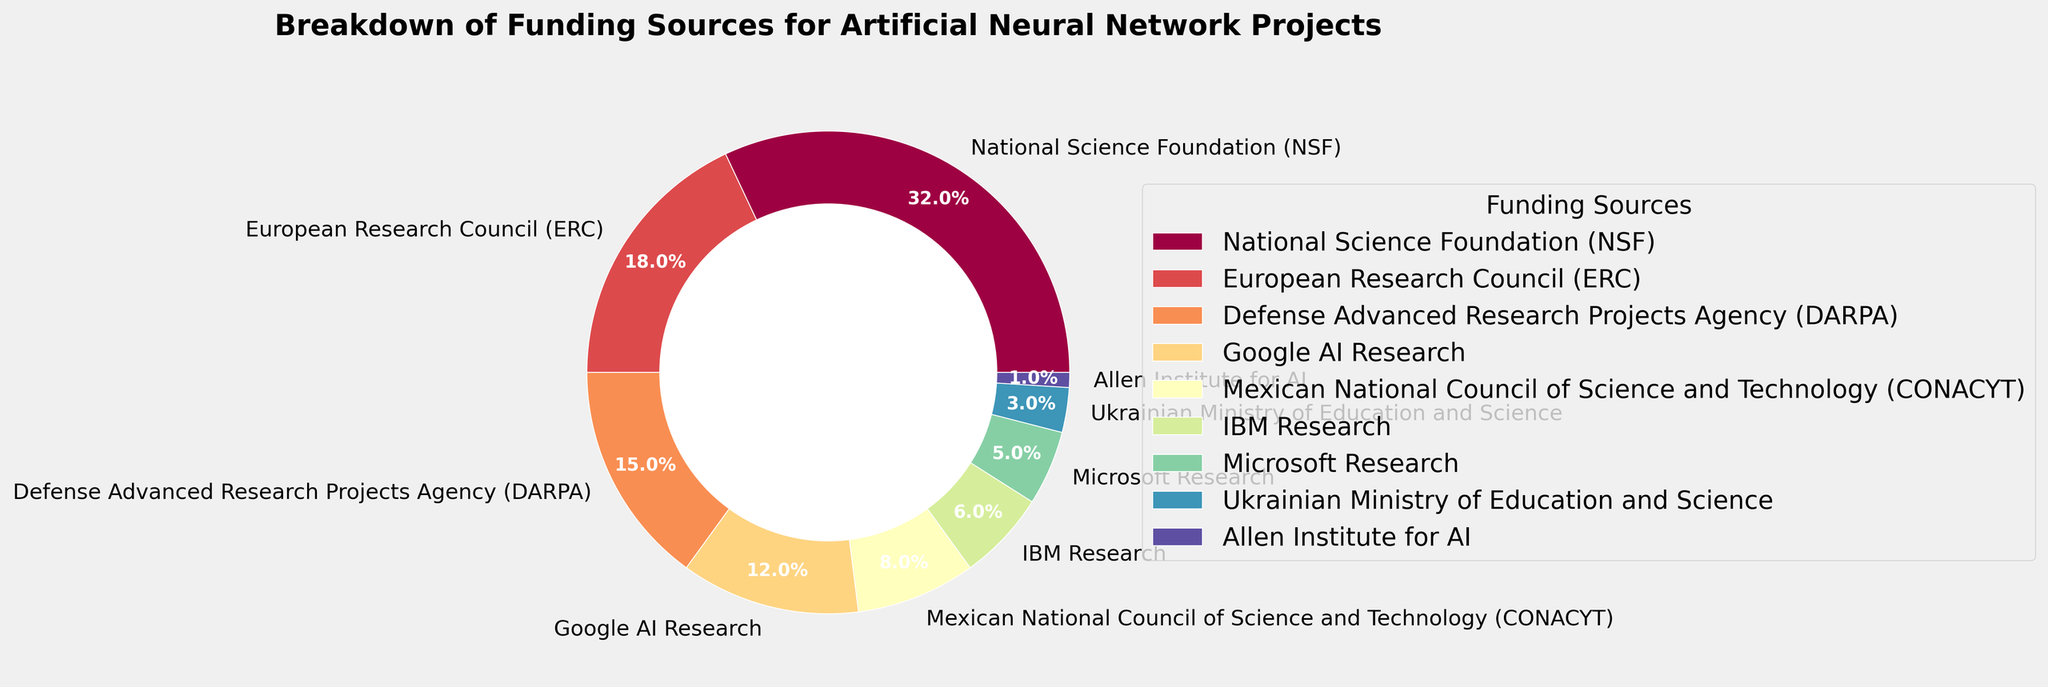what is the largest slice in the pie chart? The largest slice represents the National Science Foundation (NSF) with a 32% share of the total funding.
Answer: National Science Foundation (NSF) Which organizations contribute more than 10% each to the funding? The organizations with more than 10% share are: National Science Foundation (32%), European Research Council (18%), Defense Advanced Research Projects Agency (15%), and Google AI Research (12%).
Answer: National Science Foundation, European Research Council, Defense Advanced Research Projects Agency, Google AI Research What is the combined percentage of DARPA and ERC funding? DARPA has 15% and ERC has 18%. Adding these percentages gives 33%.
Answer: 33% Which slices are smaller than CONACYT's slice? CONACYT has 8% funding. The slices smaller than CONACYT's are IBM Research (6%), Microsoft Research (5%), Ukrainian Ministry of Education and Science (3%), and Allen Institute for AI (1%).
Answer: IBM Research, Microsoft Research, Ukrainian Ministry of Education and Science, Allen Institute for AI What is the visual difference between the slice for DARPA and the slice for Microsoft Research? The slice for DARPA is larger, comprising 15% of the pie, whereas the slice for Microsoft Research is much smaller, comprising only 5%. The visual noticeable difference is the larger area occupied by DARPA's slice.
Answer: DARPA's slice is larger What percentage of the funding is provided by non-governmental organizations (Google AI Research, IBM Research, Microsoft Research, Allen Institute for AI)? Google AI Research contributes 12%, IBM Research 6%, Microsoft Research 5%, and Allen Institute for AI 1%. Summing these percentages gives 24%.
Answer: 24% Is the contribution from the NSF greater than the combined contributions of IBM Research and Microsoft Research? NSF's contribution is 32%. The combined contributions of IBM Research and Microsoft Research are 6% + 5% = 11%. Since 32% > 11%, NSF's contribution is greater.
Answer: Yes How does the contribution of Google AI Research compare to that of the Ukrainian Ministry of Education and Science? Google AI Research contributes 12%, whereas the Ukrainian Ministry of Education and Science contributes 3%. Thus, Google AI Research's contribution is significantly larger.
Answer: Google AI Research's contribution is larger Describe the color of the slice representing the European Research Council (ERC). In the pie chart, all slices are colored using a spectral colormap ranging from lighter to darker shades. The ERC slice will be one of the unique segments mid-range in this gradient.
Answer: Mid-range spectral color What is the smallest funding source depicted in the pie chart? The smallest funding source is the Allen Institute for AI, contributing only 1% to the total funding.
Answer: Allen Institute for AI 